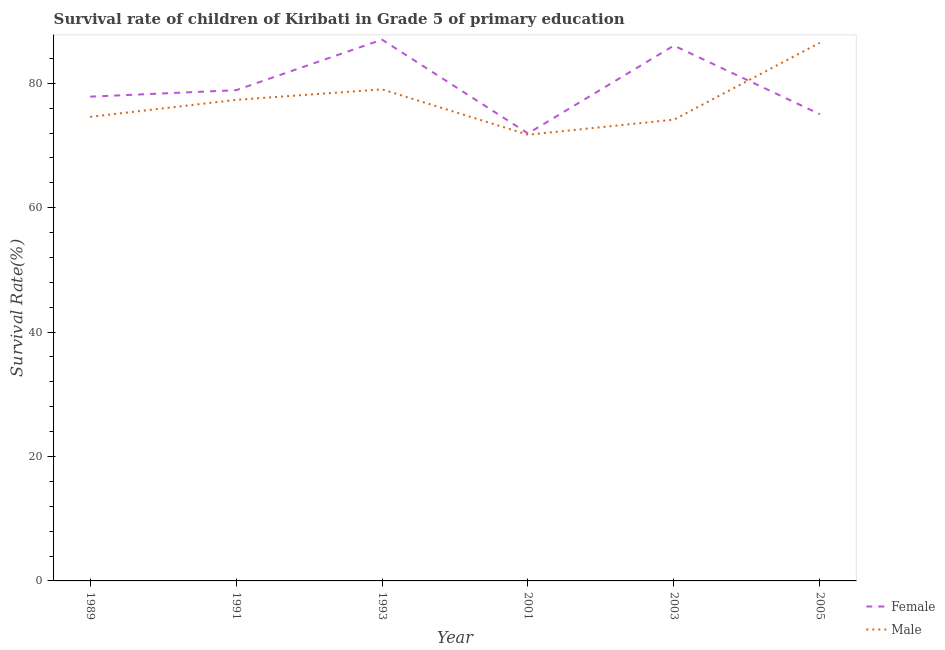How many different coloured lines are there?
Offer a very short reply. 2. Does the line corresponding to survival rate of male students in primary education intersect with the line corresponding to survival rate of female students in primary education?
Offer a very short reply. Yes. Is the number of lines equal to the number of legend labels?
Keep it short and to the point. Yes. What is the survival rate of female students in primary education in 1991?
Offer a terse response. 78.89. Across all years, what is the maximum survival rate of male students in primary education?
Make the answer very short. 86.52. Across all years, what is the minimum survival rate of female students in primary education?
Your response must be concise. 71.94. In which year was the survival rate of female students in primary education minimum?
Provide a short and direct response. 2001. What is the total survival rate of male students in primary education in the graph?
Your response must be concise. 463.38. What is the difference between the survival rate of female students in primary education in 1993 and that in 2005?
Provide a succinct answer. 11.99. What is the difference between the survival rate of female students in primary education in 1989 and the survival rate of male students in primary education in 2003?
Ensure brevity in your answer.  3.7. What is the average survival rate of male students in primary education per year?
Ensure brevity in your answer.  77.23. In the year 2003, what is the difference between the survival rate of female students in primary education and survival rate of male students in primary education?
Your answer should be very brief. 11.91. In how many years, is the survival rate of female students in primary education greater than 64 %?
Provide a succinct answer. 6. What is the ratio of the survival rate of female students in primary education in 1991 to that in 2001?
Your answer should be compact. 1.1. Is the survival rate of male students in primary education in 1993 less than that in 2003?
Your answer should be very brief. No. What is the difference between the highest and the second highest survival rate of male students in primary education?
Provide a succinct answer. 7.49. What is the difference between the highest and the lowest survival rate of female students in primary education?
Keep it short and to the point. 15.08. In how many years, is the survival rate of female students in primary education greater than the average survival rate of female students in primary education taken over all years?
Your response must be concise. 2. Is the sum of the survival rate of male students in primary education in 2003 and 2005 greater than the maximum survival rate of female students in primary education across all years?
Offer a very short reply. Yes. Does the survival rate of female students in primary education monotonically increase over the years?
Give a very brief answer. No. Is the survival rate of male students in primary education strictly greater than the survival rate of female students in primary education over the years?
Provide a succinct answer. No. How many years are there in the graph?
Your response must be concise. 6. What is the difference between two consecutive major ticks on the Y-axis?
Keep it short and to the point. 20. Are the values on the major ticks of Y-axis written in scientific E-notation?
Make the answer very short. No. Does the graph contain any zero values?
Keep it short and to the point. No. Does the graph contain grids?
Keep it short and to the point. No. How many legend labels are there?
Provide a succinct answer. 2. What is the title of the graph?
Your answer should be compact. Survival rate of children of Kiribati in Grade 5 of primary education. What is the label or title of the X-axis?
Your answer should be very brief. Year. What is the label or title of the Y-axis?
Your answer should be very brief. Survival Rate(%). What is the Survival Rate(%) in Female in 1989?
Offer a very short reply. 77.85. What is the Survival Rate(%) of Male in 1989?
Your answer should be compact. 74.61. What is the Survival Rate(%) in Female in 1991?
Offer a very short reply. 78.89. What is the Survival Rate(%) of Male in 1991?
Keep it short and to the point. 77.34. What is the Survival Rate(%) of Female in 1993?
Provide a succinct answer. 87.02. What is the Survival Rate(%) of Male in 1993?
Your answer should be very brief. 79.03. What is the Survival Rate(%) of Female in 2001?
Ensure brevity in your answer.  71.94. What is the Survival Rate(%) in Male in 2001?
Your answer should be very brief. 71.73. What is the Survival Rate(%) in Female in 2003?
Provide a short and direct response. 86.07. What is the Survival Rate(%) of Male in 2003?
Keep it short and to the point. 74.16. What is the Survival Rate(%) in Female in 2005?
Ensure brevity in your answer.  75.03. What is the Survival Rate(%) of Male in 2005?
Ensure brevity in your answer.  86.52. Across all years, what is the maximum Survival Rate(%) of Female?
Your answer should be compact. 87.02. Across all years, what is the maximum Survival Rate(%) of Male?
Provide a short and direct response. 86.52. Across all years, what is the minimum Survival Rate(%) of Female?
Offer a very short reply. 71.94. Across all years, what is the minimum Survival Rate(%) of Male?
Offer a terse response. 71.73. What is the total Survival Rate(%) in Female in the graph?
Offer a terse response. 476.81. What is the total Survival Rate(%) in Male in the graph?
Offer a terse response. 463.38. What is the difference between the Survival Rate(%) in Female in 1989 and that in 1991?
Offer a very short reply. -1.04. What is the difference between the Survival Rate(%) of Male in 1989 and that in 1991?
Your answer should be compact. -2.73. What is the difference between the Survival Rate(%) in Female in 1989 and that in 1993?
Give a very brief answer. -9.17. What is the difference between the Survival Rate(%) of Male in 1989 and that in 1993?
Your answer should be compact. -4.42. What is the difference between the Survival Rate(%) of Female in 1989 and that in 2001?
Provide a short and direct response. 5.91. What is the difference between the Survival Rate(%) in Male in 1989 and that in 2001?
Your answer should be very brief. 2.88. What is the difference between the Survival Rate(%) in Female in 1989 and that in 2003?
Provide a succinct answer. -8.21. What is the difference between the Survival Rate(%) of Male in 1989 and that in 2003?
Offer a terse response. 0.45. What is the difference between the Survival Rate(%) of Female in 1989 and that in 2005?
Ensure brevity in your answer.  2.82. What is the difference between the Survival Rate(%) of Male in 1989 and that in 2005?
Make the answer very short. -11.91. What is the difference between the Survival Rate(%) in Female in 1991 and that in 1993?
Provide a short and direct response. -8.13. What is the difference between the Survival Rate(%) in Male in 1991 and that in 1993?
Provide a succinct answer. -1.69. What is the difference between the Survival Rate(%) of Female in 1991 and that in 2001?
Your answer should be very brief. 6.95. What is the difference between the Survival Rate(%) of Male in 1991 and that in 2001?
Make the answer very short. 5.61. What is the difference between the Survival Rate(%) of Female in 1991 and that in 2003?
Your answer should be very brief. -7.17. What is the difference between the Survival Rate(%) in Male in 1991 and that in 2003?
Your answer should be compact. 3.18. What is the difference between the Survival Rate(%) of Female in 1991 and that in 2005?
Keep it short and to the point. 3.86. What is the difference between the Survival Rate(%) in Male in 1991 and that in 2005?
Your answer should be very brief. -9.18. What is the difference between the Survival Rate(%) of Female in 1993 and that in 2001?
Your response must be concise. 15.08. What is the difference between the Survival Rate(%) in Male in 1993 and that in 2001?
Offer a very short reply. 7.3. What is the difference between the Survival Rate(%) of Female in 1993 and that in 2003?
Your response must be concise. 0.96. What is the difference between the Survival Rate(%) of Male in 1993 and that in 2003?
Make the answer very short. 4.87. What is the difference between the Survival Rate(%) of Female in 1993 and that in 2005?
Offer a very short reply. 11.99. What is the difference between the Survival Rate(%) of Male in 1993 and that in 2005?
Offer a very short reply. -7.49. What is the difference between the Survival Rate(%) of Female in 2001 and that in 2003?
Offer a terse response. -14.13. What is the difference between the Survival Rate(%) in Male in 2001 and that in 2003?
Ensure brevity in your answer.  -2.43. What is the difference between the Survival Rate(%) in Female in 2001 and that in 2005?
Provide a short and direct response. -3.1. What is the difference between the Survival Rate(%) in Male in 2001 and that in 2005?
Provide a short and direct response. -14.79. What is the difference between the Survival Rate(%) in Female in 2003 and that in 2005?
Keep it short and to the point. 11.03. What is the difference between the Survival Rate(%) in Male in 2003 and that in 2005?
Offer a very short reply. -12.36. What is the difference between the Survival Rate(%) in Female in 1989 and the Survival Rate(%) in Male in 1991?
Offer a very short reply. 0.51. What is the difference between the Survival Rate(%) in Female in 1989 and the Survival Rate(%) in Male in 1993?
Provide a succinct answer. -1.17. What is the difference between the Survival Rate(%) in Female in 1989 and the Survival Rate(%) in Male in 2001?
Your response must be concise. 6.12. What is the difference between the Survival Rate(%) in Female in 1989 and the Survival Rate(%) in Male in 2003?
Provide a short and direct response. 3.7. What is the difference between the Survival Rate(%) of Female in 1989 and the Survival Rate(%) of Male in 2005?
Your response must be concise. -8.66. What is the difference between the Survival Rate(%) of Female in 1991 and the Survival Rate(%) of Male in 1993?
Make the answer very short. -0.13. What is the difference between the Survival Rate(%) of Female in 1991 and the Survival Rate(%) of Male in 2001?
Offer a very short reply. 7.16. What is the difference between the Survival Rate(%) of Female in 1991 and the Survival Rate(%) of Male in 2003?
Offer a terse response. 4.74. What is the difference between the Survival Rate(%) in Female in 1991 and the Survival Rate(%) in Male in 2005?
Provide a short and direct response. -7.62. What is the difference between the Survival Rate(%) of Female in 1993 and the Survival Rate(%) of Male in 2001?
Give a very brief answer. 15.29. What is the difference between the Survival Rate(%) in Female in 1993 and the Survival Rate(%) in Male in 2003?
Provide a short and direct response. 12.86. What is the difference between the Survival Rate(%) of Female in 1993 and the Survival Rate(%) of Male in 2005?
Give a very brief answer. 0.51. What is the difference between the Survival Rate(%) in Female in 2001 and the Survival Rate(%) in Male in 2003?
Keep it short and to the point. -2.22. What is the difference between the Survival Rate(%) of Female in 2001 and the Survival Rate(%) of Male in 2005?
Ensure brevity in your answer.  -14.58. What is the difference between the Survival Rate(%) of Female in 2003 and the Survival Rate(%) of Male in 2005?
Ensure brevity in your answer.  -0.45. What is the average Survival Rate(%) of Female per year?
Your response must be concise. 79.47. What is the average Survival Rate(%) of Male per year?
Your answer should be compact. 77.23. In the year 1989, what is the difference between the Survival Rate(%) in Female and Survival Rate(%) in Male?
Provide a succinct answer. 3.25. In the year 1991, what is the difference between the Survival Rate(%) in Female and Survival Rate(%) in Male?
Keep it short and to the point. 1.55. In the year 1993, what is the difference between the Survival Rate(%) of Female and Survival Rate(%) of Male?
Keep it short and to the point. 7.99. In the year 2001, what is the difference between the Survival Rate(%) in Female and Survival Rate(%) in Male?
Give a very brief answer. 0.21. In the year 2003, what is the difference between the Survival Rate(%) of Female and Survival Rate(%) of Male?
Make the answer very short. 11.91. In the year 2005, what is the difference between the Survival Rate(%) in Female and Survival Rate(%) in Male?
Offer a very short reply. -11.48. What is the ratio of the Survival Rate(%) in Male in 1989 to that in 1991?
Your answer should be compact. 0.96. What is the ratio of the Survival Rate(%) of Female in 1989 to that in 1993?
Your answer should be very brief. 0.89. What is the ratio of the Survival Rate(%) in Male in 1989 to that in 1993?
Offer a very short reply. 0.94. What is the ratio of the Survival Rate(%) in Female in 1989 to that in 2001?
Ensure brevity in your answer.  1.08. What is the ratio of the Survival Rate(%) in Male in 1989 to that in 2001?
Provide a short and direct response. 1.04. What is the ratio of the Survival Rate(%) in Female in 1989 to that in 2003?
Your answer should be very brief. 0.9. What is the ratio of the Survival Rate(%) of Male in 1989 to that in 2003?
Ensure brevity in your answer.  1.01. What is the ratio of the Survival Rate(%) in Female in 1989 to that in 2005?
Your answer should be very brief. 1.04. What is the ratio of the Survival Rate(%) in Male in 1989 to that in 2005?
Make the answer very short. 0.86. What is the ratio of the Survival Rate(%) of Female in 1991 to that in 1993?
Provide a succinct answer. 0.91. What is the ratio of the Survival Rate(%) in Male in 1991 to that in 1993?
Your answer should be compact. 0.98. What is the ratio of the Survival Rate(%) in Female in 1991 to that in 2001?
Give a very brief answer. 1.1. What is the ratio of the Survival Rate(%) in Male in 1991 to that in 2001?
Your response must be concise. 1.08. What is the ratio of the Survival Rate(%) in Female in 1991 to that in 2003?
Your response must be concise. 0.92. What is the ratio of the Survival Rate(%) of Male in 1991 to that in 2003?
Provide a short and direct response. 1.04. What is the ratio of the Survival Rate(%) of Female in 1991 to that in 2005?
Give a very brief answer. 1.05. What is the ratio of the Survival Rate(%) in Male in 1991 to that in 2005?
Your answer should be very brief. 0.89. What is the ratio of the Survival Rate(%) in Female in 1993 to that in 2001?
Make the answer very short. 1.21. What is the ratio of the Survival Rate(%) of Male in 1993 to that in 2001?
Your answer should be compact. 1.1. What is the ratio of the Survival Rate(%) in Female in 1993 to that in 2003?
Your answer should be compact. 1.01. What is the ratio of the Survival Rate(%) of Male in 1993 to that in 2003?
Your answer should be compact. 1.07. What is the ratio of the Survival Rate(%) in Female in 1993 to that in 2005?
Give a very brief answer. 1.16. What is the ratio of the Survival Rate(%) in Male in 1993 to that in 2005?
Offer a terse response. 0.91. What is the ratio of the Survival Rate(%) in Female in 2001 to that in 2003?
Offer a terse response. 0.84. What is the ratio of the Survival Rate(%) of Male in 2001 to that in 2003?
Give a very brief answer. 0.97. What is the ratio of the Survival Rate(%) in Female in 2001 to that in 2005?
Your answer should be very brief. 0.96. What is the ratio of the Survival Rate(%) in Male in 2001 to that in 2005?
Your answer should be compact. 0.83. What is the ratio of the Survival Rate(%) of Female in 2003 to that in 2005?
Provide a succinct answer. 1.15. What is the difference between the highest and the second highest Survival Rate(%) in Female?
Your answer should be compact. 0.96. What is the difference between the highest and the second highest Survival Rate(%) in Male?
Your answer should be compact. 7.49. What is the difference between the highest and the lowest Survival Rate(%) of Female?
Your answer should be very brief. 15.08. What is the difference between the highest and the lowest Survival Rate(%) of Male?
Your answer should be compact. 14.79. 